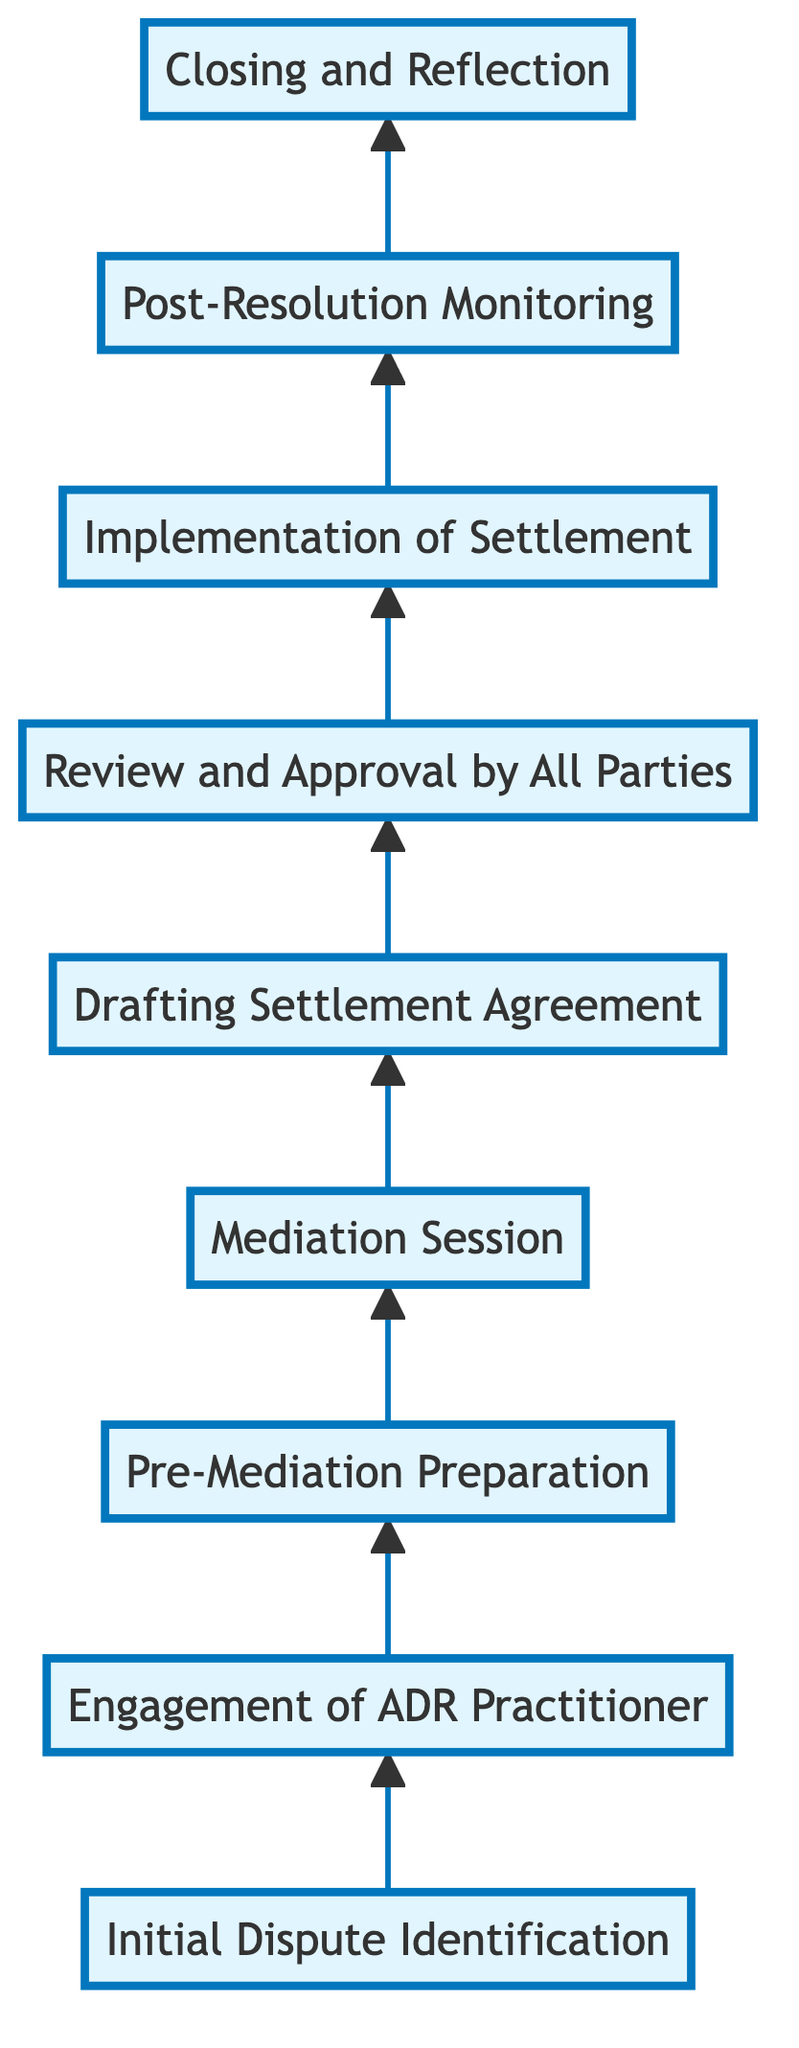What is the first stage in the process? The diagram starts with the stage labeled "Initial Dispute Identification," which is the first node at the bottom of the flowchart.
Answer: Initial Dispute Identification How many stages are present in the flowchart? By counting the nodes in the flowchart from bottom to top, there are a total of nine distinct stages listed in the diagram.
Answer: 9 What is the last stage of the dispute resolution process? The topmost node in the flowchart is labeled "Closing and Reflection," indicating it is the concluding stage of the process.
Answer: Closing and Reflection Which stage involves hiring a mediator or arbitrator? The diagram indicates that after the "Initial Dispute Identification," the next stage is "Engagement of ADR Practitioner," which is where the hiring occurs.
Answer: Engagement of ADR Practitioner What is the relationship between the stages "Mediation Session" and "Drafting Settlement Agreement"? The flowchart shows a direct arrow from "Mediation Session" to "Drafting Settlement Agreement," indicating that after mediation, drafting the agreement happens next.
Answer: Direct relationship What stage is before "Implementation of Settlement"? Looking at the flowchart, "Review and Approval by All Parties" is the stage immediately preceding "Implementation of Settlement."
Answer: Review and Approval by All Parties Which stage focuses on ensuring adherence to settlement terms? "Post-Resolution Monitoring" is the stage designated for ensuring that the terms of the settlement are followed after they have been implemented.
Answer: Post-Resolution Monitoring What is the main objective of the "Pre-Mediation Preparation" stage? This stage involves gathering relevant documents and clarifying objectives, focusing on getting ready for the mediation session.
Answer: Gathering relevant documents and clarifying objectives In which stage do parties formalize their agreement? The stage titled "Drafting Settlement Agreement" is where the parties work to formalize the agreements reached during mediation.
Answer: Drafting Settlement Agreement 